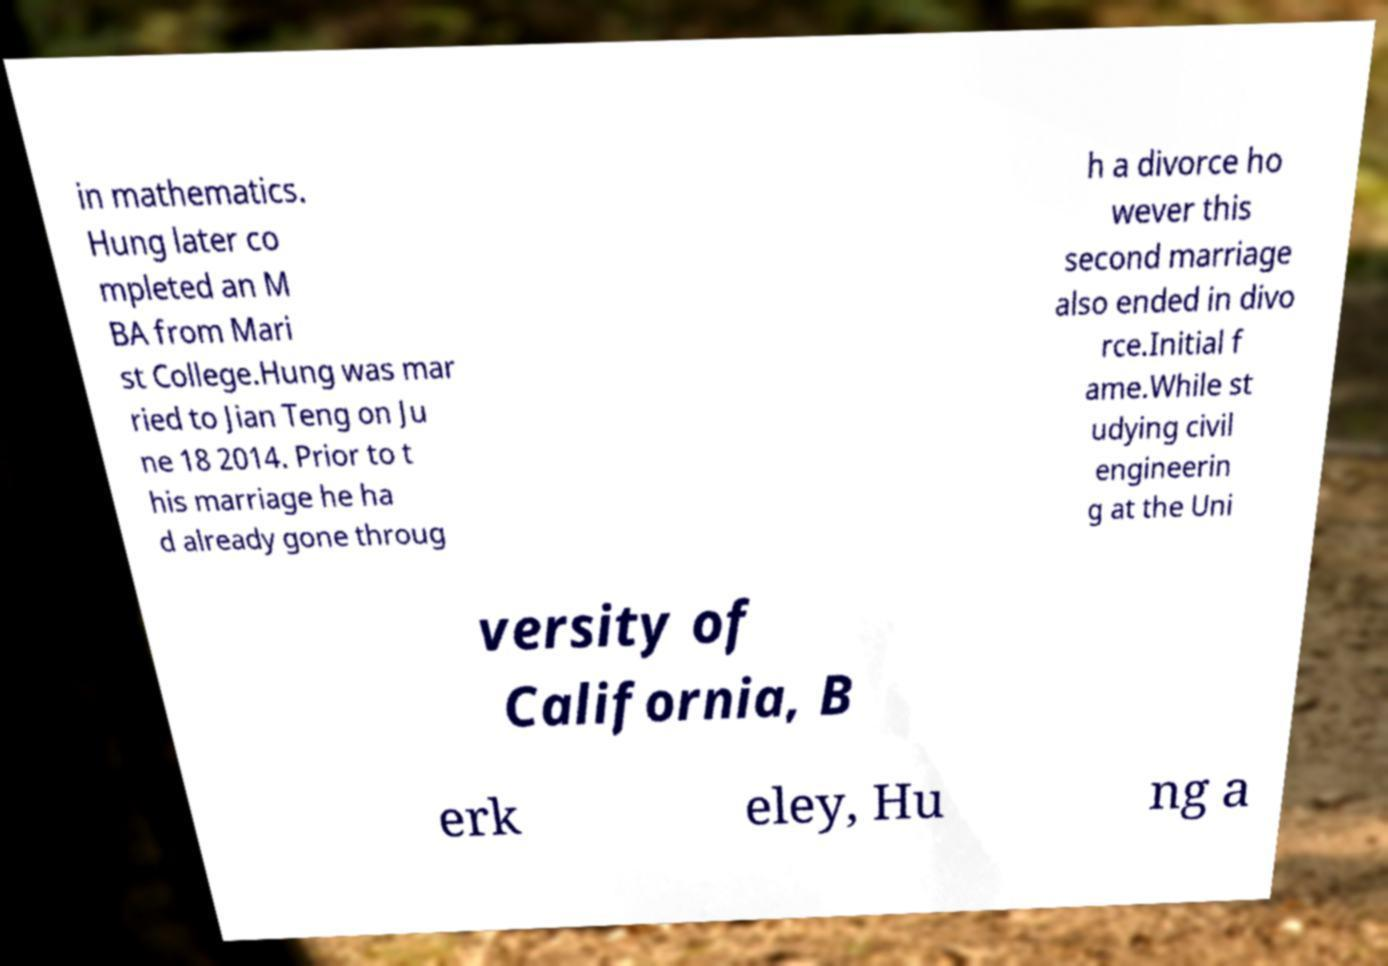Can you read and provide the text displayed in the image?This photo seems to have some interesting text. Can you extract and type it out for me? in mathematics. Hung later co mpleted an M BA from Mari st College.Hung was mar ried to Jian Teng on Ju ne 18 2014. Prior to t his marriage he ha d already gone throug h a divorce ho wever this second marriage also ended in divo rce.Initial f ame.While st udying civil engineerin g at the Uni versity of California, B erk eley, Hu ng a 